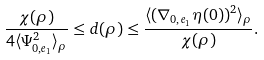<formula> <loc_0><loc_0><loc_500><loc_500>\frac { \chi ( \rho ) } { 4 \langle \Psi _ { 0 , e _ { 1 } } ^ { 2 } \rangle _ { \rho } } \leq d ( \rho ) \leq \frac { \langle ( \nabla _ { 0 , e _ { 1 } } \eta ( 0 ) ) ^ { 2 } \rangle _ { \rho } } { \chi ( \rho ) } .</formula> 